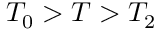Convert formula to latex. <formula><loc_0><loc_0><loc_500><loc_500>T _ { 0 } > T > T _ { 2 }</formula> 